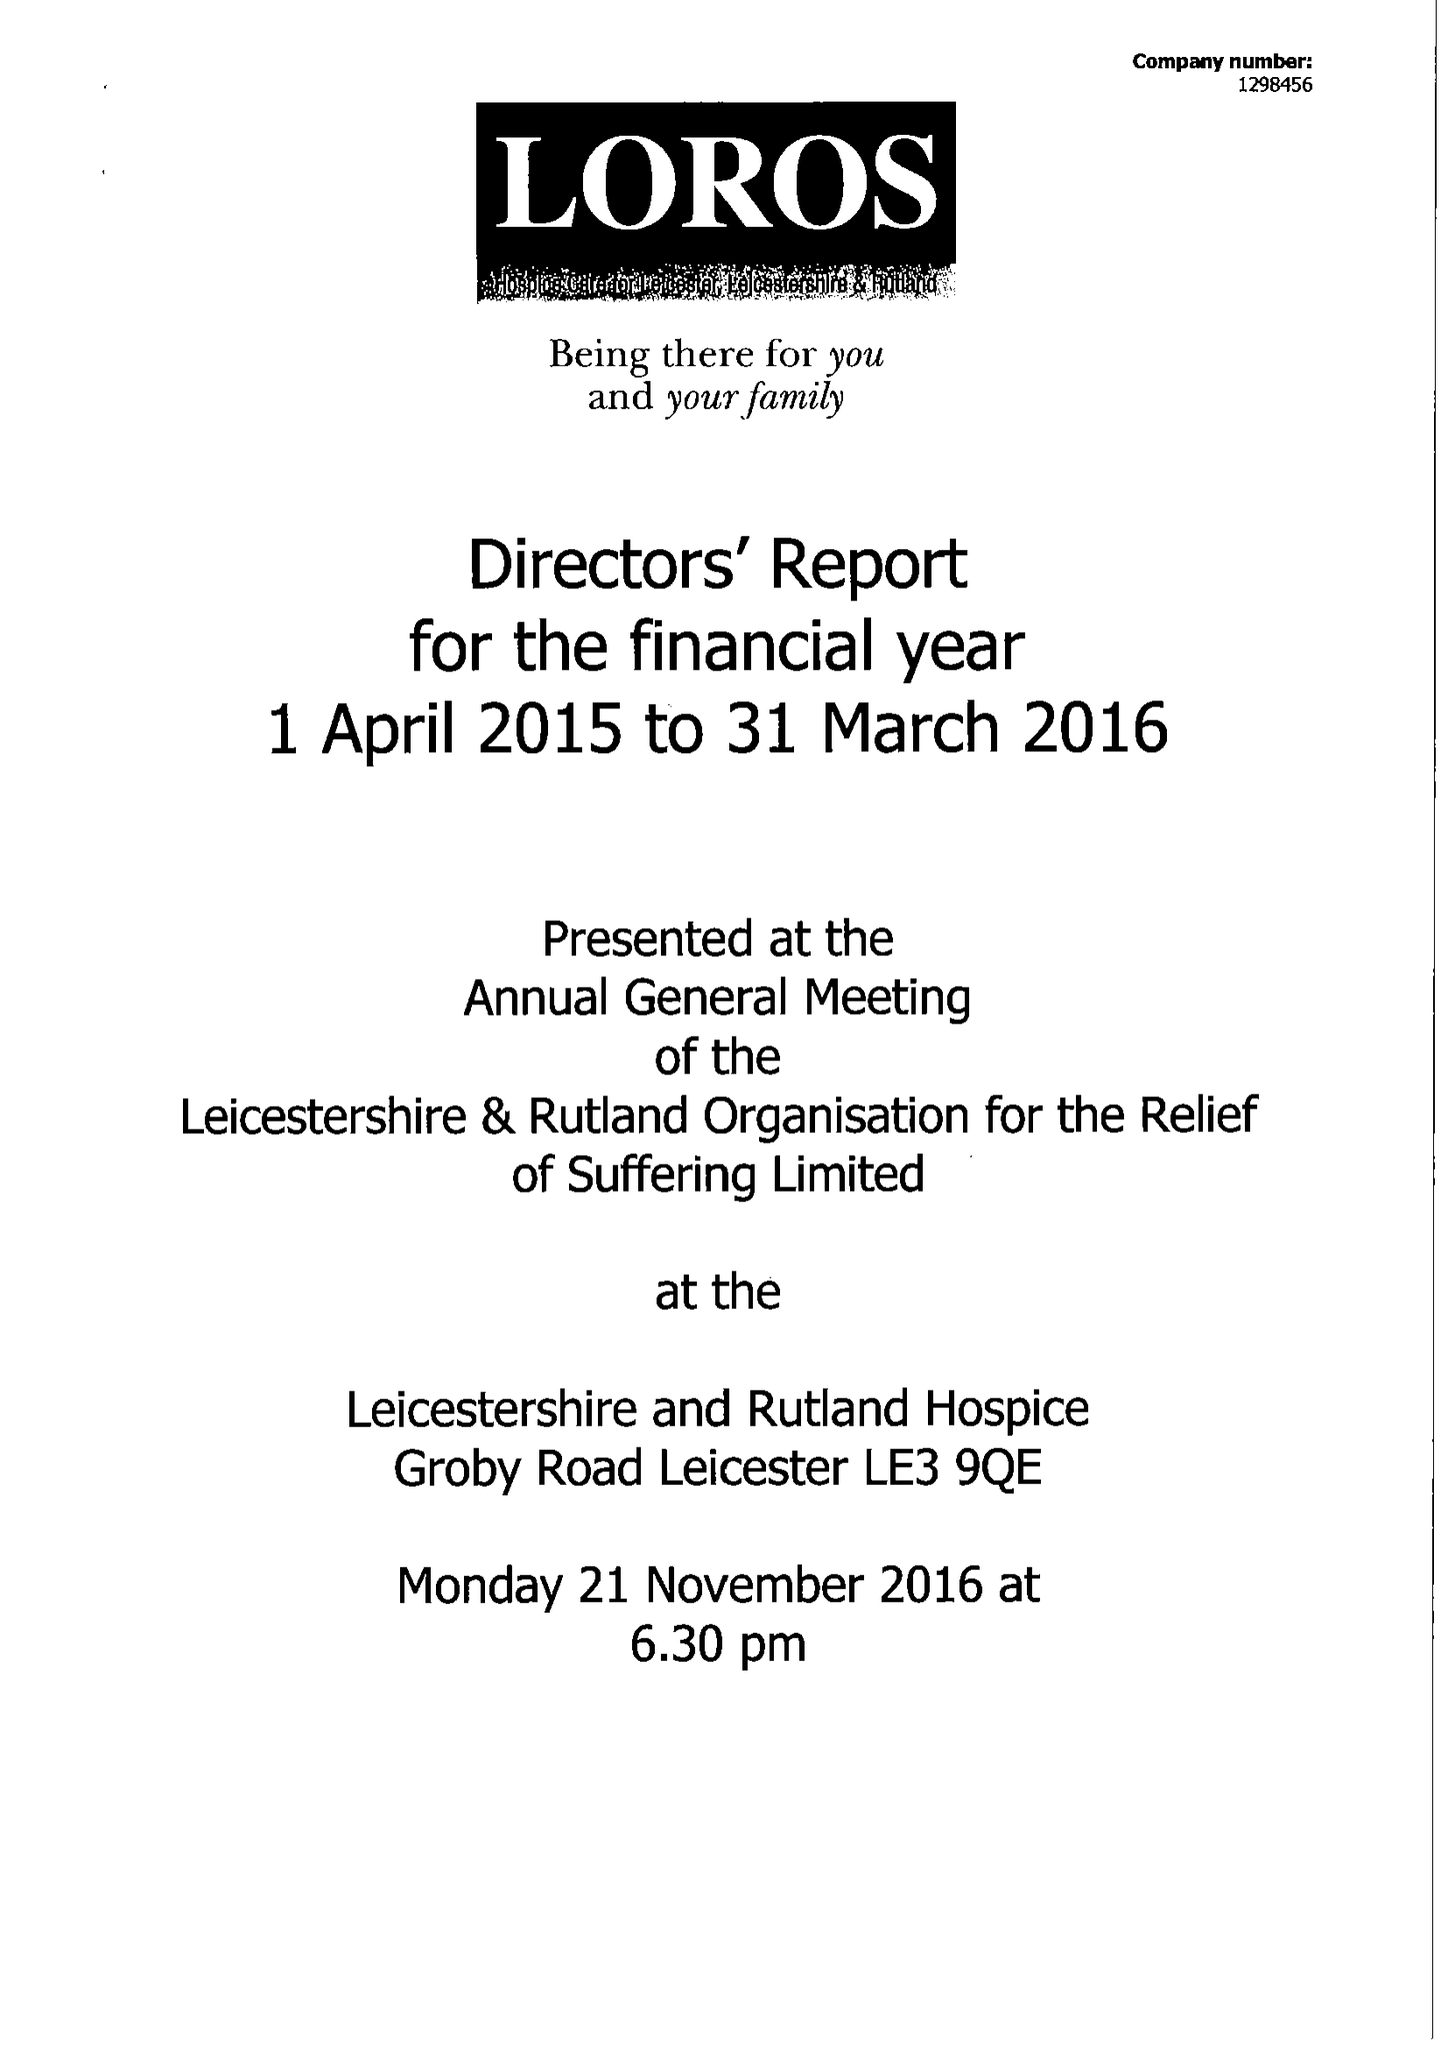What is the value for the address__post_town?
Answer the question using a single word or phrase. LEICESTER 